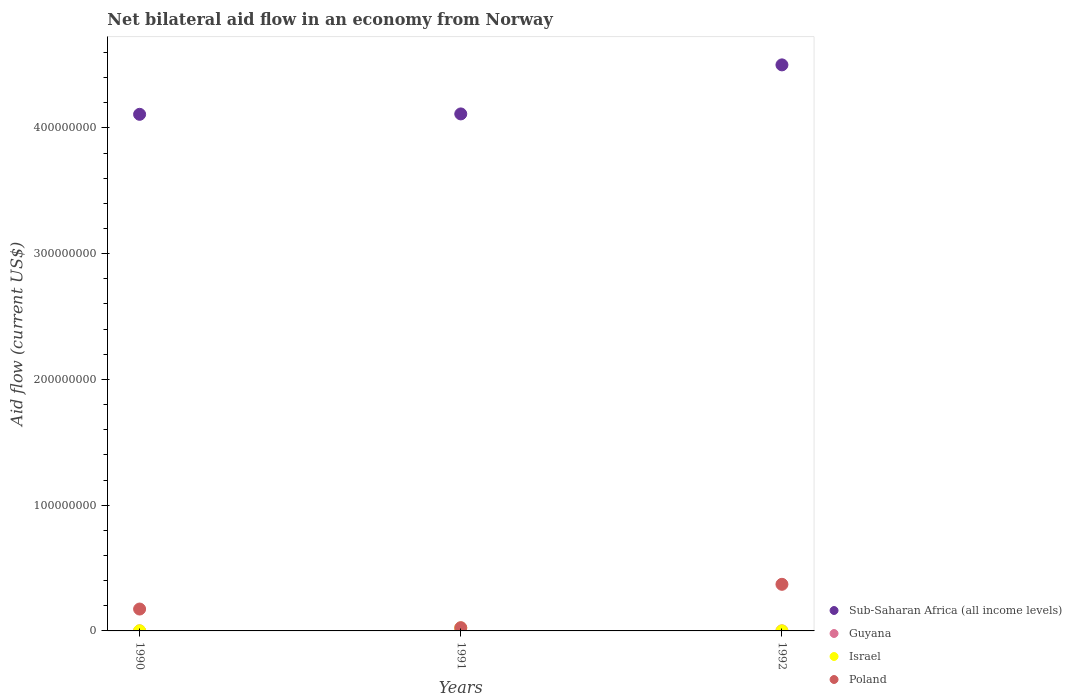Is the number of dotlines equal to the number of legend labels?
Give a very brief answer. Yes. What is the net bilateral aid flow in Sub-Saharan Africa (all income levels) in 1990?
Your answer should be very brief. 4.11e+08. Across all years, what is the maximum net bilateral aid flow in Sub-Saharan Africa (all income levels)?
Offer a terse response. 4.50e+08. Across all years, what is the minimum net bilateral aid flow in Sub-Saharan Africa (all income levels)?
Provide a succinct answer. 4.11e+08. In which year was the net bilateral aid flow in Israel minimum?
Give a very brief answer. 1992. What is the total net bilateral aid flow in Israel in the graph?
Ensure brevity in your answer.  2.41e+06. What is the difference between the net bilateral aid flow in Guyana in 1990 and that in 1991?
Your answer should be very brief. 0. What is the difference between the net bilateral aid flow in Poland in 1992 and the net bilateral aid flow in Israel in 1990?
Provide a succinct answer. 3.70e+07. What is the average net bilateral aid flow in Poland per year?
Give a very brief answer. 1.90e+07. In the year 1990, what is the difference between the net bilateral aid flow in Israel and net bilateral aid flow in Poland?
Offer a very short reply. -1.73e+07. In how many years, is the net bilateral aid flow in Guyana greater than 40000000 US$?
Your answer should be compact. 0. Is the difference between the net bilateral aid flow in Israel in 1991 and 1992 greater than the difference between the net bilateral aid flow in Poland in 1991 and 1992?
Make the answer very short. Yes. What is the difference between the highest and the lowest net bilateral aid flow in Poland?
Provide a short and direct response. 3.45e+07. In how many years, is the net bilateral aid flow in Guyana greater than the average net bilateral aid flow in Guyana taken over all years?
Your answer should be very brief. 1. Is the sum of the net bilateral aid flow in Sub-Saharan Africa (all income levels) in 1991 and 1992 greater than the maximum net bilateral aid flow in Poland across all years?
Your response must be concise. Yes. Does the net bilateral aid flow in Guyana monotonically increase over the years?
Keep it short and to the point. No. Is the net bilateral aid flow in Israel strictly greater than the net bilateral aid flow in Sub-Saharan Africa (all income levels) over the years?
Your answer should be compact. No. How many dotlines are there?
Your answer should be compact. 4. What is the difference between two consecutive major ticks on the Y-axis?
Offer a terse response. 1.00e+08. Are the values on the major ticks of Y-axis written in scientific E-notation?
Offer a terse response. No. Where does the legend appear in the graph?
Keep it short and to the point. Bottom right. How are the legend labels stacked?
Offer a terse response. Vertical. What is the title of the graph?
Provide a succinct answer. Net bilateral aid flow in an economy from Norway. Does "Iran" appear as one of the legend labels in the graph?
Offer a very short reply. No. What is the label or title of the Y-axis?
Offer a very short reply. Aid flow (current US$). What is the Aid flow (current US$) in Sub-Saharan Africa (all income levels) in 1990?
Give a very brief answer. 4.11e+08. What is the Aid flow (current US$) in Poland in 1990?
Ensure brevity in your answer.  1.74e+07. What is the Aid flow (current US$) of Sub-Saharan Africa (all income levels) in 1991?
Offer a terse response. 4.11e+08. What is the Aid flow (current US$) in Israel in 1991?
Your answer should be compact. 2.31e+06. What is the Aid flow (current US$) of Poland in 1991?
Ensure brevity in your answer.  2.59e+06. What is the Aid flow (current US$) in Sub-Saharan Africa (all income levels) in 1992?
Give a very brief answer. 4.50e+08. What is the Aid flow (current US$) in Israel in 1992?
Provide a short and direct response. 2.00e+04. What is the Aid flow (current US$) of Poland in 1992?
Offer a terse response. 3.71e+07. Across all years, what is the maximum Aid flow (current US$) in Sub-Saharan Africa (all income levels)?
Provide a short and direct response. 4.50e+08. Across all years, what is the maximum Aid flow (current US$) in Guyana?
Provide a succinct answer. 6.00e+04. Across all years, what is the maximum Aid flow (current US$) in Israel?
Your answer should be compact. 2.31e+06. Across all years, what is the maximum Aid flow (current US$) in Poland?
Offer a very short reply. 3.71e+07. Across all years, what is the minimum Aid flow (current US$) of Sub-Saharan Africa (all income levels)?
Ensure brevity in your answer.  4.11e+08. Across all years, what is the minimum Aid flow (current US$) in Guyana?
Your response must be concise. 5.00e+04. Across all years, what is the minimum Aid flow (current US$) of Poland?
Make the answer very short. 2.59e+06. What is the total Aid flow (current US$) of Sub-Saharan Africa (all income levels) in the graph?
Make the answer very short. 1.27e+09. What is the total Aid flow (current US$) in Guyana in the graph?
Make the answer very short. 1.60e+05. What is the total Aid flow (current US$) of Israel in the graph?
Your answer should be compact. 2.41e+06. What is the total Aid flow (current US$) of Poland in the graph?
Keep it short and to the point. 5.70e+07. What is the difference between the Aid flow (current US$) in Sub-Saharan Africa (all income levels) in 1990 and that in 1991?
Give a very brief answer. -3.20e+05. What is the difference between the Aid flow (current US$) in Israel in 1990 and that in 1991?
Offer a very short reply. -2.23e+06. What is the difference between the Aid flow (current US$) of Poland in 1990 and that in 1991?
Provide a succinct answer. 1.48e+07. What is the difference between the Aid flow (current US$) of Sub-Saharan Africa (all income levels) in 1990 and that in 1992?
Provide a succinct answer. -3.93e+07. What is the difference between the Aid flow (current US$) of Guyana in 1990 and that in 1992?
Provide a short and direct response. -10000. What is the difference between the Aid flow (current US$) of Poland in 1990 and that in 1992?
Keep it short and to the point. -1.97e+07. What is the difference between the Aid flow (current US$) in Sub-Saharan Africa (all income levels) in 1991 and that in 1992?
Give a very brief answer. -3.90e+07. What is the difference between the Aid flow (current US$) of Guyana in 1991 and that in 1992?
Your answer should be compact. -10000. What is the difference between the Aid flow (current US$) in Israel in 1991 and that in 1992?
Your response must be concise. 2.29e+06. What is the difference between the Aid flow (current US$) of Poland in 1991 and that in 1992?
Provide a short and direct response. -3.45e+07. What is the difference between the Aid flow (current US$) of Sub-Saharan Africa (all income levels) in 1990 and the Aid flow (current US$) of Guyana in 1991?
Your response must be concise. 4.11e+08. What is the difference between the Aid flow (current US$) in Sub-Saharan Africa (all income levels) in 1990 and the Aid flow (current US$) in Israel in 1991?
Provide a succinct answer. 4.08e+08. What is the difference between the Aid flow (current US$) in Sub-Saharan Africa (all income levels) in 1990 and the Aid flow (current US$) in Poland in 1991?
Your response must be concise. 4.08e+08. What is the difference between the Aid flow (current US$) of Guyana in 1990 and the Aid flow (current US$) of Israel in 1991?
Provide a short and direct response. -2.26e+06. What is the difference between the Aid flow (current US$) in Guyana in 1990 and the Aid flow (current US$) in Poland in 1991?
Ensure brevity in your answer.  -2.54e+06. What is the difference between the Aid flow (current US$) in Israel in 1990 and the Aid flow (current US$) in Poland in 1991?
Your answer should be very brief. -2.51e+06. What is the difference between the Aid flow (current US$) in Sub-Saharan Africa (all income levels) in 1990 and the Aid flow (current US$) in Guyana in 1992?
Provide a short and direct response. 4.11e+08. What is the difference between the Aid flow (current US$) of Sub-Saharan Africa (all income levels) in 1990 and the Aid flow (current US$) of Israel in 1992?
Provide a succinct answer. 4.11e+08. What is the difference between the Aid flow (current US$) in Sub-Saharan Africa (all income levels) in 1990 and the Aid flow (current US$) in Poland in 1992?
Offer a very short reply. 3.74e+08. What is the difference between the Aid flow (current US$) in Guyana in 1990 and the Aid flow (current US$) in Israel in 1992?
Offer a very short reply. 3.00e+04. What is the difference between the Aid flow (current US$) in Guyana in 1990 and the Aid flow (current US$) in Poland in 1992?
Keep it short and to the point. -3.70e+07. What is the difference between the Aid flow (current US$) of Israel in 1990 and the Aid flow (current US$) of Poland in 1992?
Make the answer very short. -3.70e+07. What is the difference between the Aid flow (current US$) of Sub-Saharan Africa (all income levels) in 1991 and the Aid flow (current US$) of Guyana in 1992?
Offer a very short reply. 4.11e+08. What is the difference between the Aid flow (current US$) of Sub-Saharan Africa (all income levels) in 1991 and the Aid flow (current US$) of Israel in 1992?
Provide a succinct answer. 4.11e+08. What is the difference between the Aid flow (current US$) in Sub-Saharan Africa (all income levels) in 1991 and the Aid flow (current US$) in Poland in 1992?
Offer a terse response. 3.74e+08. What is the difference between the Aid flow (current US$) of Guyana in 1991 and the Aid flow (current US$) of Israel in 1992?
Your response must be concise. 3.00e+04. What is the difference between the Aid flow (current US$) of Guyana in 1991 and the Aid flow (current US$) of Poland in 1992?
Provide a short and direct response. -3.70e+07. What is the difference between the Aid flow (current US$) in Israel in 1991 and the Aid flow (current US$) in Poland in 1992?
Your answer should be compact. -3.48e+07. What is the average Aid flow (current US$) of Sub-Saharan Africa (all income levels) per year?
Offer a terse response. 4.24e+08. What is the average Aid flow (current US$) of Guyana per year?
Your answer should be very brief. 5.33e+04. What is the average Aid flow (current US$) in Israel per year?
Your response must be concise. 8.03e+05. What is the average Aid flow (current US$) in Poland per year?
Provide a succinct answer. 1.90e+07. In the year 1990, what is the difference between the Aid flow (current US$) in Sub-Saharan Africa (all income levels) and Aid flow (current US$) in Guyana?
Offer a very short reply. 4.11e+08. In the year 1990, what is the difference between the Aid flow (current US$) in Sub-Saharan Africa (all income levels) and Aid flow (current US$) in Israel?
Your answer should be compact. 4.11e+08. In the year 1990, what is the difference between the Aid flow (current US$) of Sub-Saharan Africa (all income levels) and Aid flow (current US$) of Poland?
Keep it short and to the point. 3.93e+08. In the year 1990, what is the difference between the Aid flow (current US$) in Guyana and Aid flow (current US$) in Poland?
Ensure brevity in your answer.  -1.74e+07. In the year 1990, what is the difference between the Aid flow (current US$) in Israel and Aid flow (current US$) in Poland?
Offer a terse response. -1.73e+07. In the year 1991, what is the difference between the Aid flow (current US$) in Sub-Saharan Africa (all income levels) and Aid flow (current US$) in Guyana?
Your response must be concise. 4.11e+08. In the year 1991, what is the difference between the Aid flow (current US$) in Sub-Saharan Africa (all income levels) and Aid flow (current US$) in Israel?
Provide a short and direct response. 4.09e+08. In the year 1991, what is the difference between the Aid flow (current US$) of Sub-Saharan Africa (all income levels) and Aid flow (current US$) of Poland?
Give a very brief answer. 4.09e+08. In the year 1991, what is the difference between the Aid flow (current US$) of Guyana and Aid flow (current US$) of Israel?
Offer a terse response. -2.26e+06. In the year 1991, what is the difference between the Aid flow (current US$) in Guyana and Aid flow (current US$) in Poland?
Make the answer very short. -2.54e+06. In the year 1991, what is the difference between the Aid flow (current US$) of Israel and Aid flow (current US$) of Poland?
Keep it short and to the point. -2.80e+05. In the year 1992, what is the difference between the Aid flow (current US$) in Sub-Saharan Africa (all income levels) and Aid flow (current US$) in Guyana?
Your answer should be very brief. 4.50e+08. In the year 1992, what is the difference between the Aid flow (current US$) in Sub-Saharan Africa (all income levels) and Aid flow (current US$) in Israel?
Your answer should be compact. 4.50e+08. In the year 1992, what is the difference between the Aid flow (current US$) in Sub-Saharan Africa (all income levels) and Aid flow (current US$) in Poland?
Your answer should be compact. 4.13e+08. In the year 1992, what is the difference between the Aid flow (current US$) in Guyana and Aid flow (current US$) in Poland?
Provide a succinct answer. -3.70e+07. In the year 1992, what is the difference between the Aid flow (current US$) in Israel and Aid flow (current US$) in Poland?
Offer a very short reply. -3.70e+07. What is the ratio of the Aid flow (current US$) in Sub-Saharan Africa (all income levels) in 1990 to that in 1991?
Provide a short and direct response. 1. What is the ratio of the Aid flow (current US$) of Israel in 1990 to that in 1991?
Provide a succinct answer. 0.03. What is the ratio of the Aid flow (current US$) in Poland in 1990 to that in 1991?
Your answer should be compact. 6.72. What is the ratio of the Aid flow (current US$) of Sub-Saharan Africa (all income levels) in 1990 to that in 1992?
Ensure brevity in your answer.  0.91. What is the ratio of the Aid flow (current US$) of Israel in 1990 to that in 1992?
Make the answer very short. 4. What is the ratio of the Aid flow (current US$) in Poland in 1990 to that in 1992?
Your answer should be very brief. 0.47. What is the ratio of the Aid flow (current US$) in Sub-Saharan Africa (all income levels) in 1991 to that in 1992?
Ensure brevity in your answer.  0.91. What is the ratio of the Aid flow (current US$) in Israel in 1991 to that in 1992?
Provide a short and direct response. 115.5. What is the ratio of the Aid flow (current US$) of Poland in 1991 to that in 1992?
Your response must be concise. 0.07. What is the difference between the highest and the second highest Aid flow (current US$) in Sub-Saharan Africa (all income levels)?
Ensure brevity in your answer.  3.90e+07. What is the difference between the highest and the second highest Aid flow (current US$) of Israel?
Your answer should be very brief. 2.23e+06. What is the difference between the highest and the second highest Aid flow (current US$) of Poland?
Give a very brief answer. 1.97e+07. What is the difference between the highest and the lowest Aid flow (current US$) of Sub-Saharan Africa (all income levels)?
Your response must be concise. 3.93e+07. What is the difference between the highest and the lowest Aid flow (current US$) in Guyana?
Offer a terse response. 10000. What is the difference between the highest and the lowest Aid flow (current US$) of Israel?
Your answer should be very brief. 2.29e+06. What is the difference between the highest and the lowest Aid flow (current US$) of Poland?
Provide a succinct answer. 3.45e+07. 